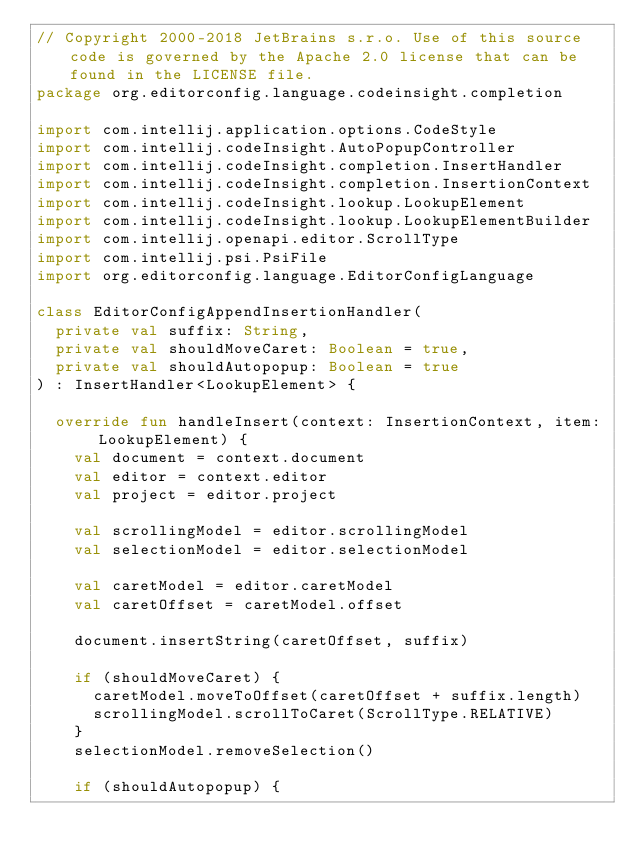<code> <loc_0><loc_0><loc_500><loc_500><_Kotlin_>// Copyright 2000-2018 JetBrains s.r.o. Use of this source code is governed by the Apache 2.0 license that can be found in the LICENSE file.
package org.editorconfig.language.codeinsight.completion

import com.intellij.application.options.CodeStyle
import com.intellij.codeInsight.AutoPopupController
import com.intellij.codeInsight.completion.InsertHandler
import com.intellij.codeInsight.completion.InsertionContext
import com.intellij.codeInsight.lookup.LookupElement
import com.intellij.codeInsight.lookup.LookupElementBuilder
import com.intellij.openapi.editor.ScrollType
import com.intellij.psi.PsiFile
import org.editorconfig.language.EditorConfigLanguage

class EditorConfigAppendInsertionHandler(
  private val suffix: String,
  private val shouldMoveCaret: Boolean = true,
  private val shouldAutopopup: Boolean = true
) : InsertHandler<LookupElement> {

  override fun handleInsert(context: InsertionContext, item: LookupElement) {
    val document = context.document
    val editor = context.editor
    val project = editor.project

    val scrollingModel = editor.scrollingModel
    val selectionModel = editor.selectionModel

    val caretModel = editor.caretModel
    val caretOffset = caretModel.offset

    document.insertString(caretOffset, suffix)

    if (shouldMoveCaret) {
      caretModel.moveToOffset(caretOffset + suffix.length)
      scrollingModel.scrollToCaret(ScrollType.RELATIVE)
    }
    selectionModel.removeSelection()

    if (shouldAutopopup) {</code> 